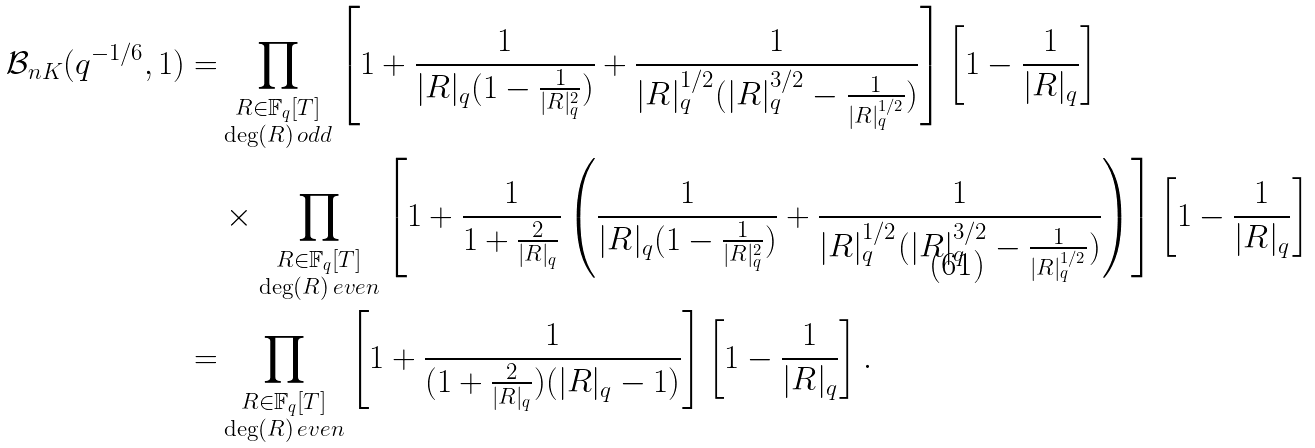Convert formula to latex. <formula><loc_0><loc_0><loc_500><loc_500>\mathcal { B } _ { n K } ( q ^ { - 1 / 6 } , 1 ) = & \prod _ { \substack { R \in \mathbb { F } _ { q } [ T ] \\ \deg ( R ) \, o d d } } \left [ 1 + \frac { 1 } { | R | _ { q } ( 1 - \frac { 1 } { | R | _ { q } ^ { 2 } } ) } + \frac { 1 } { | R | _ { q } ^ { 1 / 2 } ( | R | _ { q } ^ { 3 / 2 } - \frac { 1 } { | R | _ { q } ^ { 1 / 2 } } ) } \right ] \left [ 1 - \frac { 1 } { | R | _ { q } } \right ] \\ & \times \prod _ { \substack { R \in \mathbb { F } _ { q } [ T ] \\ \deg ( R ) \, e v e n } } \left [ 1 + \frac { 1 } { 1 + \frac { 2 } { | R | _ { q } } } \left ( \frac { 1 } { | R | _ { q } ( 1 - \frac { 1 } { | R | _ { q } ^ { 2 } } ) } + \frac { 1 } { | R | _ { q } ^ { 1 / 2 } ( | R | _ { q } ^ { 3 / 2 } - \frac { 1 } { | R | _ { q } ^ { 1 / 2 } } ) } \right ) \right ] \left [ 1 - \frac { 1 } { | R | _ { q } } \right ] \\ = & \prod _ { \substack { R \in \mathbb { F } _ { q } [ T ] \\ \deg ( R ) \, e v e n } } \left [ 1 + \frac { 1 } { ( 1 + \frac { 2 } { | R | _ { q } } ) ( | R | _ { q } - 1 ) } \right ] \left [ 1 - \frac { 1 } { | R | _ { q } } \right ] .</formula> 